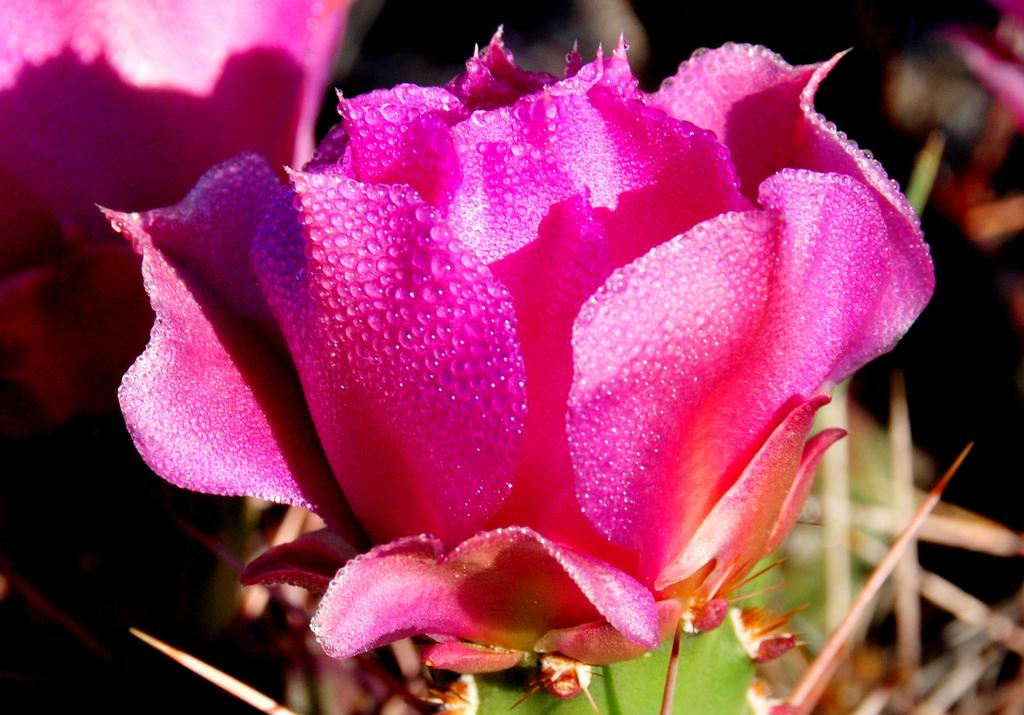What type of flower is in the image? There is a pink rose in the image. What features can be observed on the rose? The rose has thorns at the bottom and leaves. How would you describe the background of the image? The background of the image is blurred. What else can be seen in the background of the image? There are roses and a plant in the background. What type of bottle is the farmer holding next to his brother in the image? There is no bottle, farmer, or brother present in the image; it features a pink rose with thorns and leaves, and a blurred background with additional roses and a plant. 